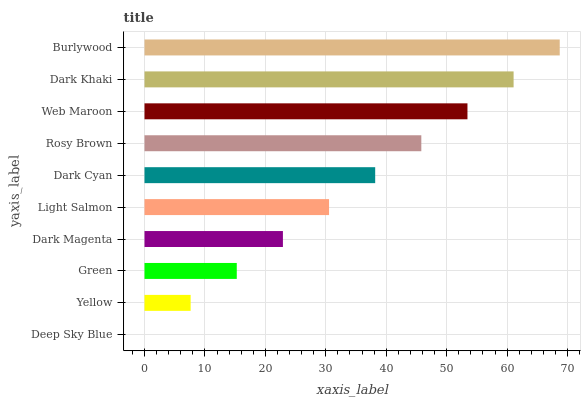Is Deep Sky Blue the minimum?
Answer yes or no. Yes. Is Burlywood the maximum?
Answer yes or no. Yes. Is Yellow the minimum?
Answer yes or no. No. Is Yellow the maximum?
Answer yes or no. No. Is Yellow greater than Deep Sky Blue?
Answer yes or no. Yes. Is Deep Sky Blue less than Yellow?
Answer yes or no. Yes. Is Deep Sky Blue greater than Yellow?
Answer yes or no. No. Is Yellow less than Deep Sky Blue?
Answer yes or no. No. Is Dark Cyan the high median?
Answer yes or no. Yes. Is Light Salmon the low median?
Answer yes or no. Yes. Is Dark Magenta the high median?
Answer yes or no. No. Is Dark Cyan the low median?
Answer yes or no. No. 